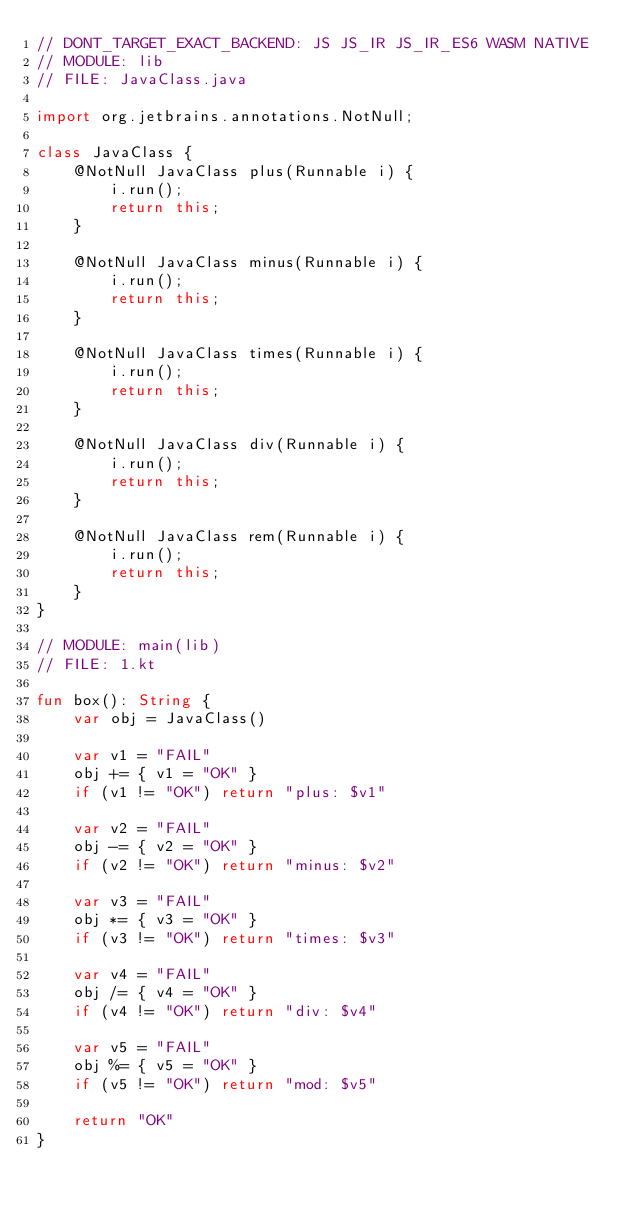Convert code to text. <code><loc_0><loc_0><loc_500><loc_500><_Kotlin_>// DONT_TARGET_EXACT_BACKEND: JS JS_IR JS_IR_ES6 WASM NATIVE
// MODULE: lib
// FILE: JavaClass.java

import org.jetbrains.annotations.NotNull;

class JavaClass {
    @NotNull JavaClass plus(Runnable i) {
        i.run();
        return this;
    }

    @NotNull JavaClass minus(Runnable i) {
        i.run();
        return this;
    }

    @NotNull JavaClass times(Runnable i) {
        i.run();
        return this;
    }

    @NotNull JavaClass div(Runnable i) {
        i.run();
        return this;
    }

    @NotNull JavaClass rem(Runnable i) {
        i.run();
        return this;
    }
}

// MODULE: main(lib)
// FILE: 1.kt

fun box(): String {
    var obj = JavaClass()

    var v1 = "FAIL"
    obj += { v1 = "OK" }
    if (v1 != "OK") return "plus: $v1"

    var v2 = "FAIL"
    obj -= { v2 = "OK" }
    if (v2 != "OK") return "minus: $v2"

    var v3 = "FAIL"
    obj *= { v3 = "OK" }
    if (v3 != "OK") return "times: $v3"

    var v4 = "FAIL"
    obj /= { v4 = "OK" }
    if (v4 != "OK") return "div: $v4"

    var v5 = "FAIL"
    obj %= { v5 = "OK" }
    if (v5 != "OK") return "mod: $v5"

    return "OK"
}
</code> 